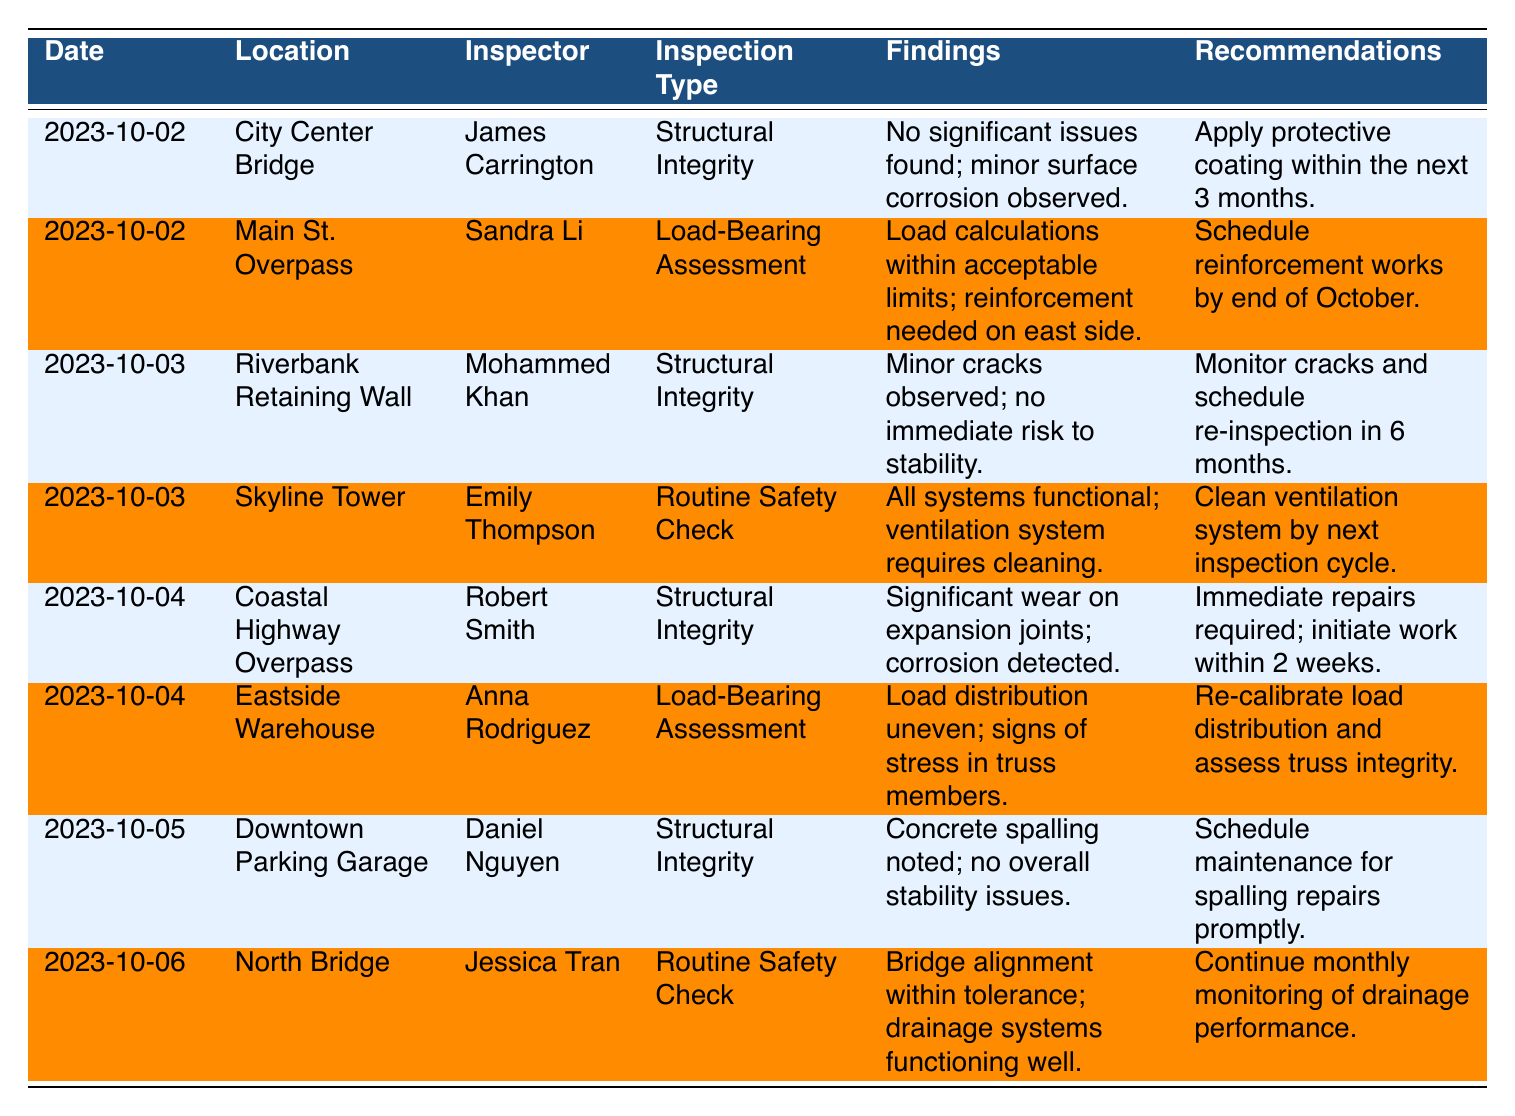What is the inspection type for the report dated 2023-10-05? Referring to the table, locate the row with the date 2023-10-05, which indicates that the inspection type is "Structural Integrity."
Answer: Structural Integrity Which inspector conducted the inspection at the Coastal Highway Overpass? Check the entry for the Coastal Highway Overpass in the table, and it shows that the inspector is Robert Smith.
Answer: Robert Smith How many inspections were conducted on 2023-10-02? Look at the table and identify the rows with the date 2023-10-02. There are two entries for that date, which are for the City Center Bridge and Main St. Overpass.
Answer: 2 Is there a recommendation to apply protective coating for any inspection? Reviewing the findings and recommendations, the report for the City Center Bridge suggests applying a protective coating within the next 3 months.
Answer: Yes What is the main concern noted in the inspection for the Eastside Warehouse? In the row for Eastside Warehouse, the findings indicate that the load distribution is uneven and there are signs of stress in truss members.
Answer: Uneven load distribution and stress signs Which locations had significant findings that required immediate action? Several entries need review: the Coastal Highway Overpass requires immediate repairs, and the Eastside Warehouse needs recalibration for load distribution. Therefore, both have significant findings needing action.
Answer: Coastal Highway Overpass and Eastside Warehouse What is the average inspection type found in the reports? There are four types of inspections: Structural Integrity (4 instances), Load-Bearing Assessment (2 instances), Routine Safety Check (2 instances). To find the average type, the total is 8, with 4 being the most common.
Answer: Structural Integrity How many reports note no immediate risk to stability? Analyzing the table, the reports for the Riverbank Retaining Wall and Downtown Parking Garage confirm "no immediate risk to stability." Thus, there are two such reports.
Answer: 2 Which inspector had the most entries across all reports? By counting the entries for each inspector: James Carrington (1), Sandra Li (1), Mohammed Khan (1), Emily Thompson (1), Robert Smith (1), Anna Rodriguez (1), Daniel Nguyen (1), Jessica Tran (1). All have one entry, so no single inspector has more than one.
Answer: None, all inspectors have one entry 